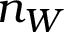<formula> <loc_0><loc_0><loc_500><loc_500>n _ { W }</formula> 